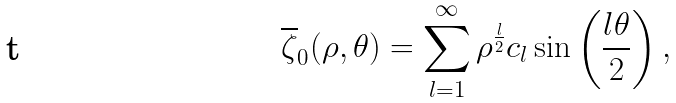Convert formula to latex. <formula><loc_0><loc_0><loc_500><loc_500>\overline { \zeta } _ { 0 } ( \rho , \theta ) = \sum _ { l = 1 } ^ { \infty } \rho ^ { \frac { l } { 2 } } c _ { l } \sin \left ( \frac { l \theta } { 2 } \right ) ,</formula> 